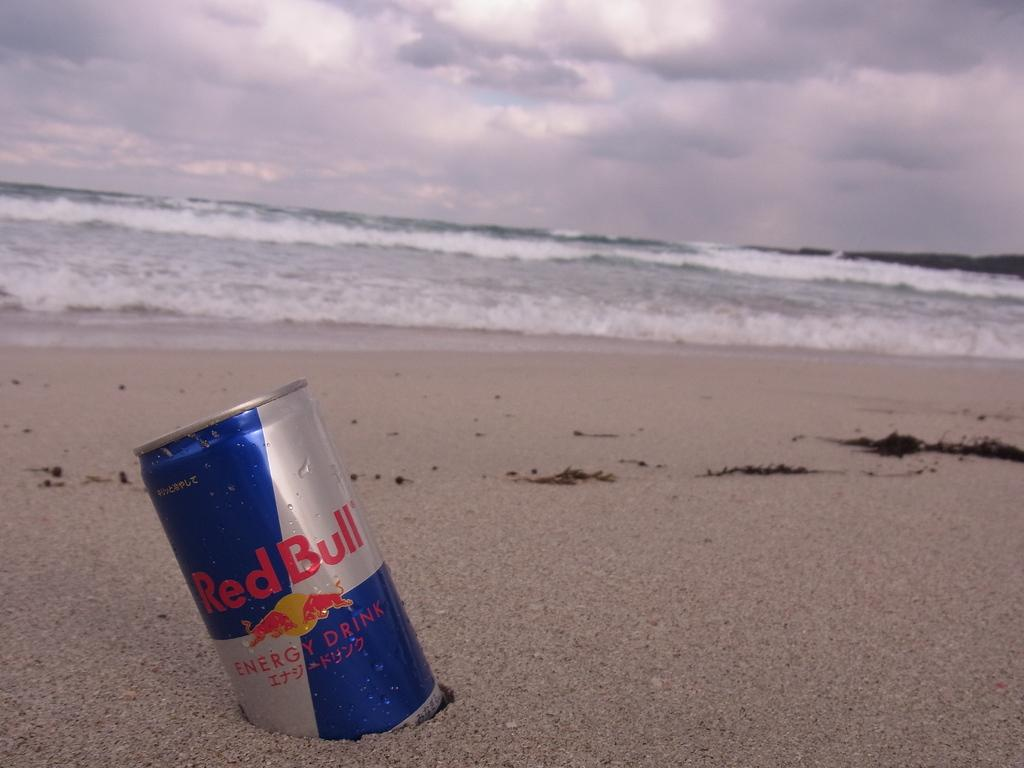<image>
Write a terse but informative summary of the picture. A can marked Red Bull Energy Drink is partially buried in the sand at a beach. 